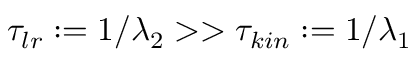<formula> <loc_0><loc_0><loc_500><loc_500>\tau _ { l r } \colon = 1 / \lambda _ { 2 } > > \tau _ { k i n } \colon = 1 / \lambda _ { 1 }</formula> 